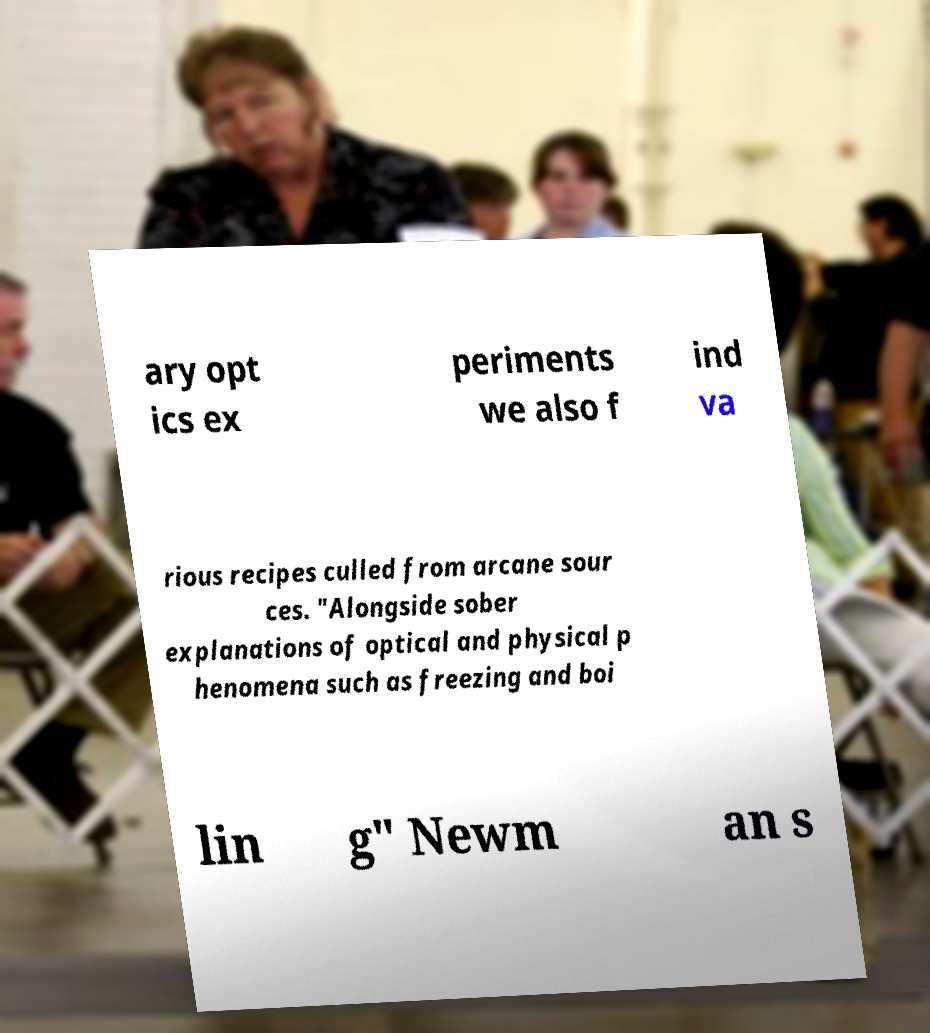What messages or text are displayed in this image? I need them in a readable, typed format. ary opt ics ex periments we also f ind va rious recipes culled from arcane sour ces. "Alongside sober explanations of optical and physical p henomena such as freezing and boi lin g" Newm an s 